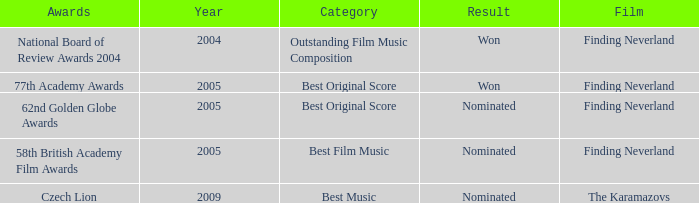How many years were there for the 62nd golden globe awards? 2005.0. 